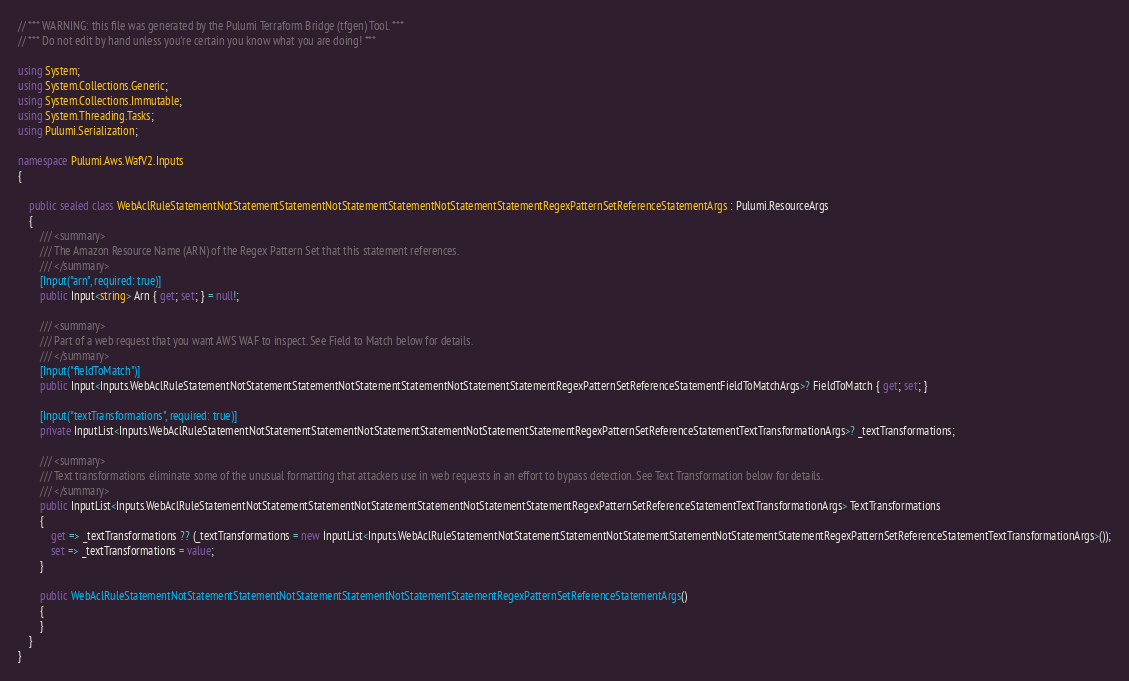Convert code to text. <code><loc_0><loc_0><loc_500><loc_500><_C#_>// *** WARNING: this file was generated by the Pulumi Terraform Bridge (tfgen) Tool. ***
// *** Do not edit by hand unless you're certain you know what you are doing! ***

using System;
using System.Collections.Generic;
using System.Collections.Immutable;
using System.Threading.Tasks;
using Pulumi.Serialization;

namespace Pulumi.Aws.WafV2.Inputs
{

    public sealed class WebAclRuleStatementNotStatementStatementNotStatementStatementNotStatementStatementRegexPatternSetReferenceStatementArgs : Pulumi.ResourceArgs
    {
        /// <summary>
        /// The Amazon Resource Name (ARN) of the Regex Pattern Set that this statement references.
        /// </summary>
        [Input("arn", required: true)]
        public Input<string> Arn { get; set; } = null!;

        /// <summary>
        /// Part of a web request that you want AWS WAF to inspect. See Field to Match below for details.
        /// </summary>
        [Input("fieldToMatch")]
        public Input<Inputs.WebAclRuleStatementNotStatementStatementNotStatementStatementNotStatementStatementRegexPatternSetReferenceStatementFieldToMatchArgs>? FieldToMatch { get; set; }

        [Input("textTransformations", required: true)]
        private InputList<Inputs.WebAclRuleStatementNotStatementStatementNotStatementStatementNotStatementStatementRegexPatternSetReferenceStatementTextTransformationArgs>? _textTransformations;

        /// <summary>
        /// Text transformations eliminate some of the unusual formatting that attackers use in web requests in an effort to bypass detection. See Text Transformation below for details.
        /// </summary>
        public InputList<Inputs.WebAclRuleStatementNotStatementStatementNotStatementStatementNotStatementStatementRegexPatternSetReferenceStatementTextTransformationArgs> TextTransformations
        {
            get => _textTransformations ?? (_textTransformations = new InputList<Inputs.WebAclRuleStatementNotStatementStatementNotStatementStatementNotStatementStatementRegexPatternSetReferenceStatementTextTransformationArgs>());
            set => _textTransformations = value;
        }

        public WebAclRuleStatementNotStatementStatementNotStatementStatementNotStatementStatementRegexPatternSetReferenceStatementArgs()
        {
        }
    }
}
</code> 